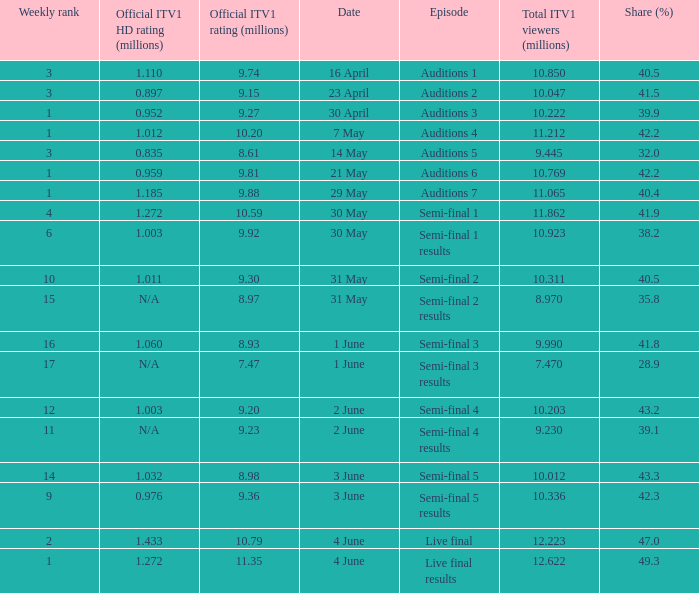What was the share (%) for the Semi-Final 2 episode?  40.5. 